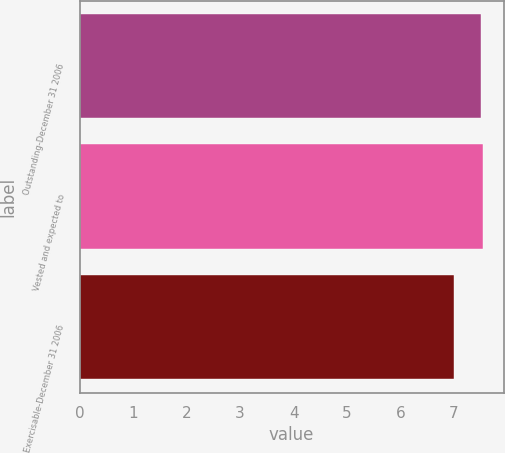<chart> <loc_0><loc_0><loc_500><loc_500><bar_chart><fcel>Outstanding-December 31 2006<fcel>Vested and expected to<fcel>Exercisable-December 31 2006<nl><fcel>7.5<fcel>7.55<fcel>7<nl></chart> 